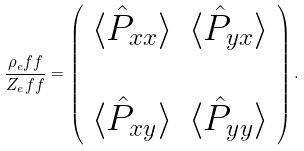<formula> <loc_0><loc_0><loc_500><loc_500>\frac { \rho _ { e } f f } { Z _ { e } f f } = \left ( \begin{array} { c c } \langle \hat { P } _ { x x } \rangle & \langle \hat { P } _ { y x } \rangle \\ \\ \langle \hat { P } _ { x y } \rangle & \langle \hat { P } _ { y y } \rangle \end{array} \right ) .</formula> 